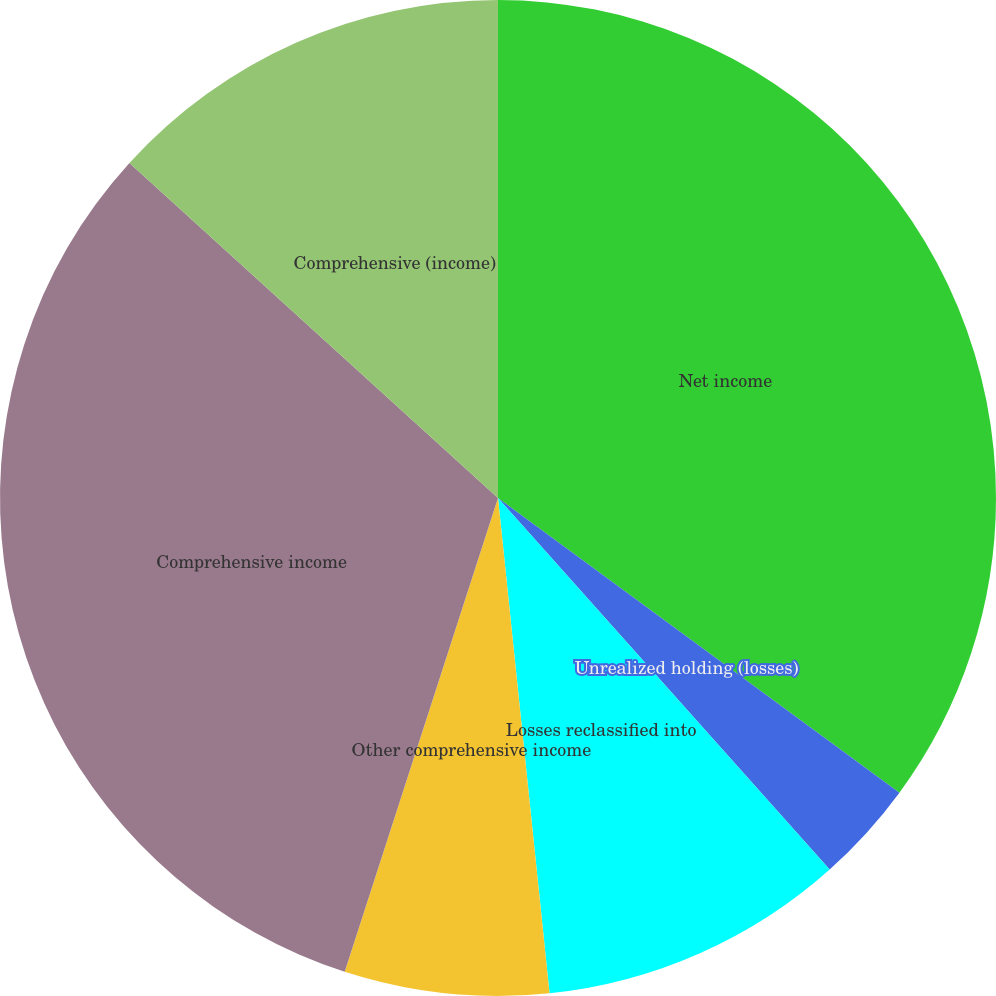<chart> <loc_0><loc_0><loc_500><loc_500><pie_chart><fcel>Net income<fcel>Unrealized holding (losses)<fcel>Losses reclassified into<fcel>Currency translation<fcel>Other comprehensive income<fcel>Comprehensive income<fcel>Comprehensive (income)<nl><fcel>35.08%<fcel>3.32%<fcel>9.95%<fcel>0.0%<fcel>6.63%<fcel>31.76%<fcel>13.26%<nl></chart> 